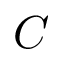Convert formula to latex. <formula><loc_0><loc_0><loc_500><loc_500>C</formula> 